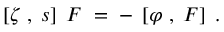Convert formula to latex. <formula><loc_0><loc_0><loc_500><loc_500>\left [ \zeta \, , \, s \right ] \, F \, = \, - \, \left [ \varphi \, , \, F \right ] \, .</formula> 